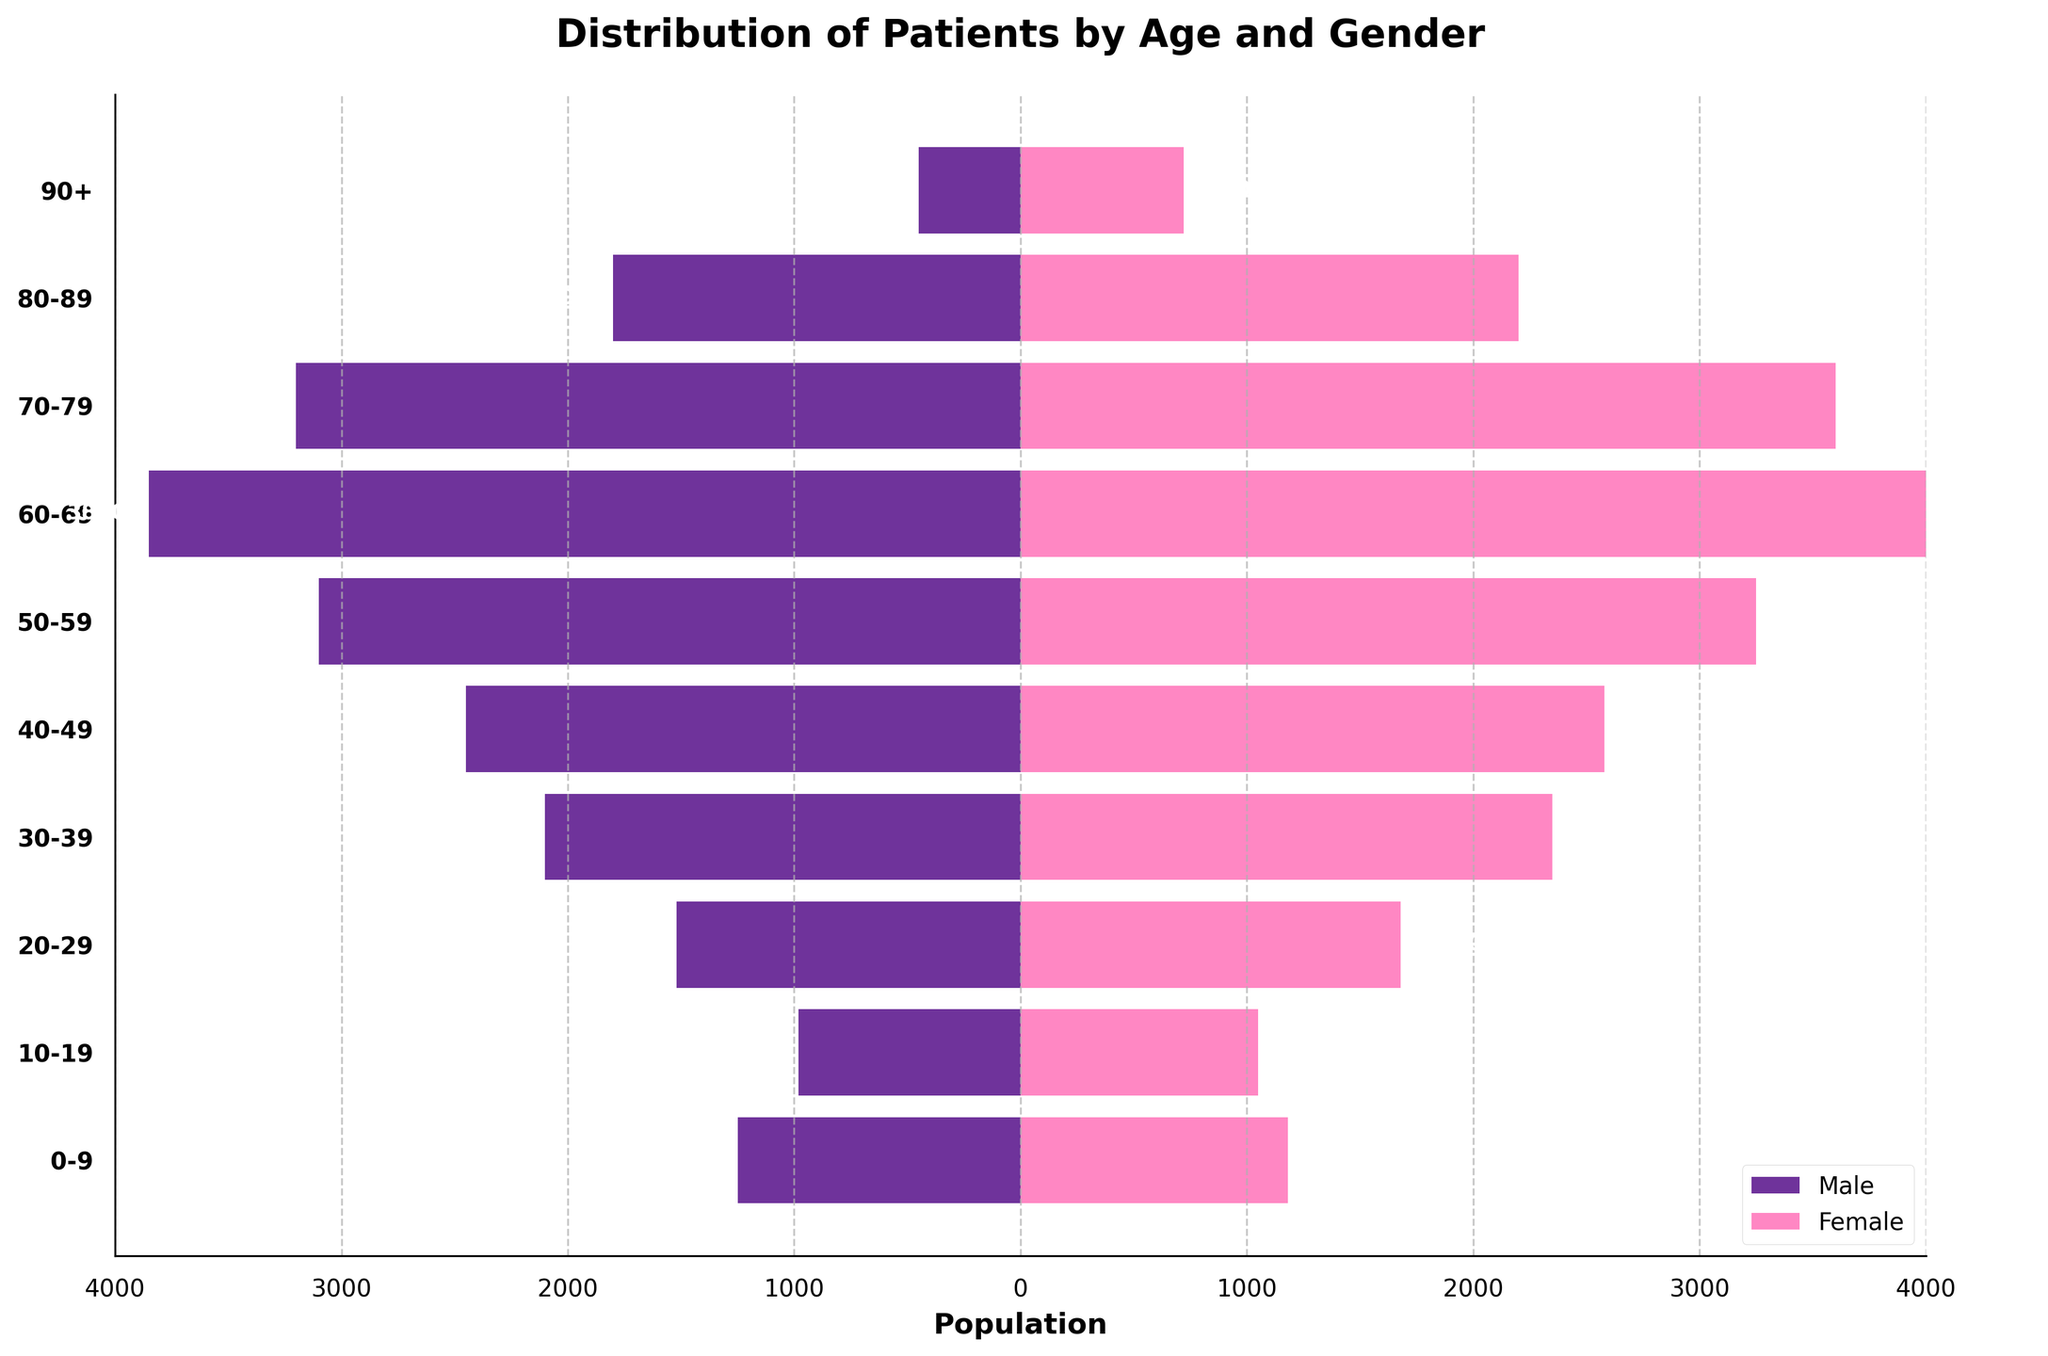what is the title of the figure? The title is usually located at the top of the figure. By observing there, you can see the written text.
Answer: Distribution of Patients by Age and Gender How many age groups are present in the data? To determine the number of age groups, count the distinct bars or labels on the y-axis.
Answer: 10 What color represents female patients in the figure? The colors used to represent male and female patients can be seen in the legend at the bottom-right corner of the figure.
Answer: Pink Which age group has the highest number of male patients? Look at the lengths of the horizontal bars on the left side of the figure; the longest bar represents the age group with the highest number of male patients.
Answer: 60-69 How many more female patients are there than male patients in the 80-89 age group? Subtract the number of male patients from the number of female patients in the 80-89 age group by comparing the corresponding bars.
Answer: 400 What is the total number of patients in the 30-39 age group? Add the number of male and female patients in the 30-39 age group by summing the lengths of the respective bars.
Answer: 4450 Which age group has the narrowest difference in the number of male and female patients? Calculate the difference between the number of male and female patients for each age group and find the smallest difference.
Answer: 10-19 What trend do you observe in the male patient population from the 0-9 age group to the 70-79 age group? Observe the lengths of the horizontal bars on the left side for each successive age group, noting the changes in length.
Answer: Increasing If we combine the number of patients from the 50-59 and 60-69 age groups, what is the total population? Add the total number of patients (both male and female) from the 50-59 and 60-69 age groups.
Answer: 14300 